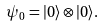<formula> <loc_0><loc_0><loc_500><loc_500>\psi _ { 0 } = | 0 \rangle \otimes | 0 \rangle .</formula> 